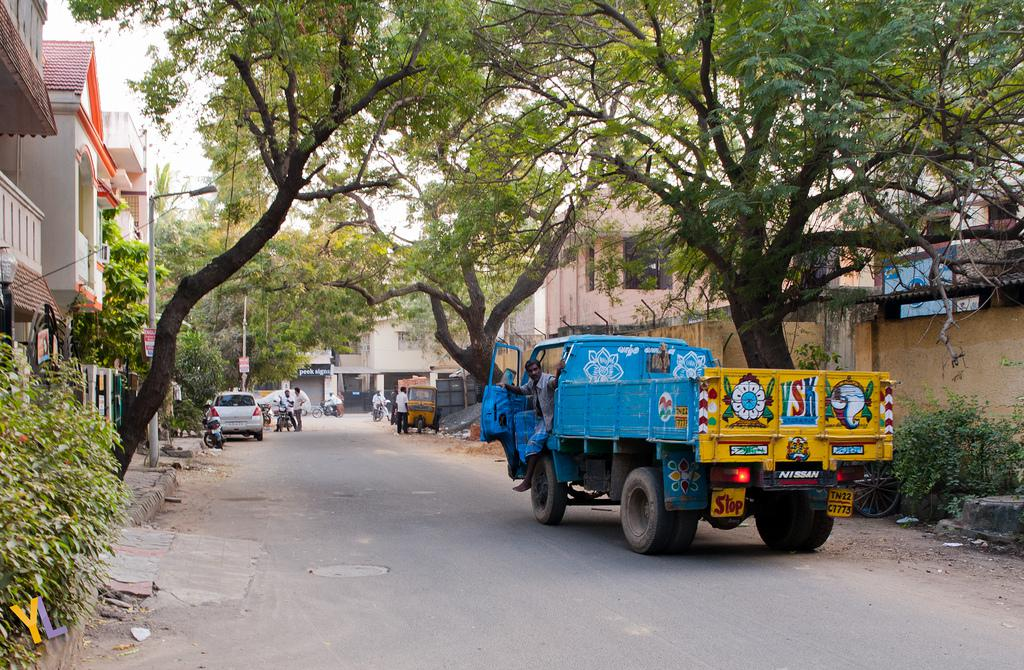Question: what is yellow and blue?
Choices:
A. The car.
B. The van.
C. The truck.
D. The bus.
Answer with the letter. Answer: C Question: what color is the 'y'?
Choices:
A. Red.
B. Green.
C. Pink.
D. Yellow.
Answer with the letter. Answer: D Question: what color is the house?
Choices:
A. Brown.
B. Green.
C. Gray.
D. White.
Answer with the letter. Answer: D Question: what color is the road?
Choices:
A. Red.
B. Blue.
C. Gray.
D. Green.
Answer with the letter. Answer: C Question: how many cars are in the picture?
Choices:
A. 1.
B. 2.
C. 3.
D. 9.
Answer with the letter. Answer: C Question: how many houses are there?
Choices:
A. Three.
B. Four.
C. Six.
D. Five.
Answer with the letter. Answer: C Question: what time of day is it?
Choices:
A. Noon.
B. Morning.
C. Evening.
D. Afternoon.
Answer with the letter. Answer: D Question: how is a tree slanted?
Choices:
A. To the right.
B. To the left.
C. To the back.
D. To the front.
Answer with the letter. Answer: A Question: where was the photo taken?
Choices:
A. Downtown.
B. On a town street.
C. Outside.
D. At the courthouse.
Answer with the letter. Answer: B Question: how does the street appear?
Choices:
A. Empty.
B. Barren.
C. Tree lined.
D. Full of flowers.
Answer with the letter. Answer: C Question: where are the trees?
Choices:
A. In the middle of the street.
B. On the left.
C. On the right.
D. Both sides of street.
Answer with the letter. Answer: D Question: what type of trees are there?
Choices:
A. Oak.
B. Pine.
C. Hickory.
D. Mahogany.
Answer with the letter. Answer: A Question: where are there more people?
Choices:
A. In the distance.
B. Close by.
C. To the right.
D. Over on the left.
Answer with the letter. Answer: A Question: what is on the trees?
Choices:
A. Many leaves.
B. A bird.
C. A swing.
D. A sign.
Answer with the letter. Answer: A Question: how is the weather?
Choices:
A. It is a raining day.
B. It is a sunny day.
C. It is a cloudy day.
D. It is a snowy day.
Answer with the letter. Answer: C Question: who has an open door?
Choices:
A. A house.
B. A truck.
C. A tent.
D. A van.
Answer with the letter. Answer: B 